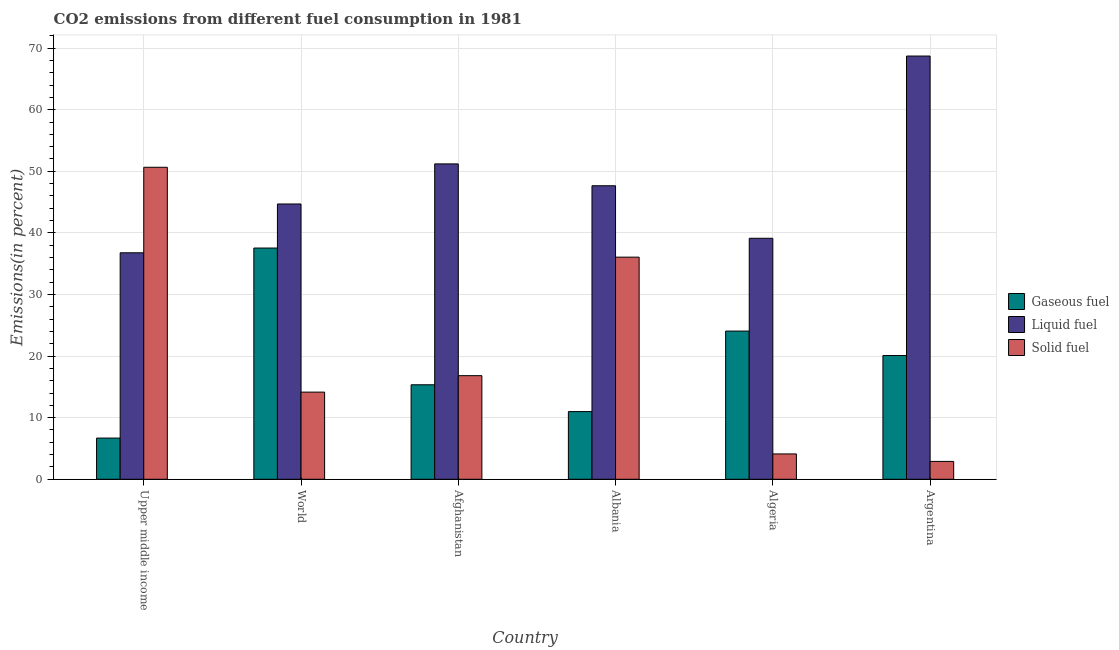How many different coloured bars are there?
Your answer should be very brief. 3. Are the number of bars per tick equal to the number of legend labels?
Your response must be concise. Yes. Are the number of bars on each tick of the X-axis equal?
Your answer should be compact. Yes. How many bars are there on the 1st tick from the left?
Your answer should be very brief. 3. In how many cases, is the number of bars for a given country not equal to the number of legend labels?
Give a very brief answer. 0. What is the percentage of liquid fuel emission in Albania?
Your response must be concise. 47.65. Across all countries, what is the maximum percentage of gaseous fuel emission?
Offer a terse response. 37.54. Across all countries, what is the minimum percentage of gaseous fuel emission?
Your response must be concise. 6.69. In which country was the percentage of gaseous fuel emission minimum?
Offer a very short reply. Upper middle income. What is the total percentage of liquid fuel emission in the graph?
Give a very brief answer. 288.16. What is the difference between the percentage of solid fuel emission in Upper middle income and that in World?
Offer a very short reply. 36.5. What is the difference between the percentage of solid fuel emission in Afghanistan and the percentage of gaseous fuel emission in Algeria?
Make the answer very short. -7.24. What is the average percentage of solid fuel emission per country?
Give a very brief answer. 20.78. What is the difference between the percentage of solid fuel emission and percentage of liquid fuel emission in Argentina?
Your answer should be compact. -65.81. In how many countries, is the percentage of gaseous fuel emission greater than 6 %?
Offer a terse response. 6. What is the ratio of the percentage of liquid fuel emission in Algeria to that in Argentina?
Provide a succinct answer. 0.57. What is the difference between the highest and the second highest percentage of liquid fuel emission?
Your response must be concise. 17.51. What is the difference between the highest and the lowest percentage of solid fuel emission?
Provide a short and direct response. 47.75. In how many countries, is the percentage of gaseous fuel emission greater than the average percentage of gaseous fuel emission taken over all countries?
Provide a short and direct response. 3. What does the 2nd bar from the left in World represents?
Provide a short and direct response. Liquid fuel. What does the 2nd bar from the right in Afghanistan represents?
Make the answer very short. Liquid fuel. Is it the case that in every country, the sum of the percentage of gaseous fuel emission and percentage of liquid fuel emission is greater than the percentage of solid fuel emission?
Provide a short and direct response. No. How many bars are there?
Make the answer very short. 18. Does the graph contain any zero values?
Offer a very short reply. No. Where does the legend appear in the graph?
Provide a succinct answer. Center right. How many legend labels are there?
Give a very brief answer. 3. How are the legend labels stacked?
Ensure brevity in your answer.  Vertical. What is the title of the graph?
Provide a succinct answer. CO2 emissions from different fuel consumption in 1981. What is the label or title of the Y-axis?
Keep it short and to the point. Emissions(in percent). What is the Emissions(in percent) in Gaseous fuel in Upper middle income?
Provide a succinct answer. 6.69. What is the Emissions(in percent) of Liquid fuel in Upper middle income?
Your response must be concise. 36.77. What is the Emissions(in percent) in Solid fuel in Upper middle income?
Offer a very short reply. 50.65. What is the Emissions(in percent) in Gaseous fuel in World?
Offer a very short reply. 37.54. What is the Emissions(in percent) in Liquid fuel in World?
Keep it short and to the point. 44.69. What is the Emissions(in percent) of Solid fuel in World?
Give a very brief answer. 14.15. What is the Emissions(in percent) in Gaseous fuel in Afghanistan?
Ensure brevity in your answer.  15.34. What is the Emissions(in percent) of Liquid fuel in Afghanistan?
Make the answer very short. 51.2. What is the Emissions(in percent) in Solid fuel in Afghanistan?
Provide a succinct answer. 16.82. What is the Emissions(in percent) in Gaseous fuel in Albania?
Offer a very short reply. 10.99. What is the Emissions(in percent) of Liquid fuel in Albania?
Give a very brief answer. 47.65. What is the Emissions(in percent) of Solid fuel in Albania?
Your response must be concise. 36.06. What is the Emissions(in percent) of Gaseous fuel in Algeria?
Offer a terse response. 24.06. What is the Emissions(in percent) in Liquid fuel in Algeria?
Your answer should be compact. 39.13. What is the Emissions(in percent) in Solid fuel in Algeria?
Make the answer very short. 4.11. What is the Emissions(in percent) in Gaseous fuel in Argentina?
Your answer should be compact. 20.09. What is the Emissions(in percent) in Liquid fuel in Argentina?
Your response must be concise. 68.71. What is the Emissions(in percent) in Solid fuel in Argentina?
Make the answer very short. 2.9. Across all countries, what is the maximum Emissions(in percent) in Gaseous fuel?
Your response must be concise. 37.54. Across all countries, what is the maximum Emissions(in percent) in Liquid fuel?
Give a very brief answer. 68.71. Across all countries, what is the maximum Emissions(in percent) in Solid fuel?
Your response must be concise. 50.65. Across all countries, what is the minimum Emissions(in percent) of Gaseous fuel?
Keep it short and to the point. 6.69. Across all countries, what is the minimum Emissions(in percent) of Liquid fuel?
Keep it short and to the point. 36.77. Across all countries, what is the minimum Emissions(in percent) of Solid fuel?
Provide a short and direct response. 2.9. What is the total Emissions(in percent) in Gaseous fuel in the graph?
Give a very brief answer. 114.72. What is the total Emissions(in percent) of Liquid fuel in the graph?
Make the answer very short. 288.16. What is the total Emissions(in percent) of Solid fuel in the graph?
Ensure brevity in your answer.  124.7. What is the difference between the Emissions(in percent) of Gaseous fuel in Upper middle income and that in World?
Your answer should be compact. -30.85. What is the difference between the Emissions(in percent) of Liquid fuel in Upper middle income and that in World?
Your response must be concise. -7.92. What is the difference between the Emissions(in percent) in Solid fuel in Upper middle income and that in World?
Provide a short and direct response. 36.51. What is the difference between the Emissions(in percent) of Gaseous fuel in Upper middle income and that in Afghanistan?
Your response must be concise. -8.65. What is the difference between the Emissions(in percent) of Liquid fuel in Upper middle income and that in Afghanistan?
Ensure brevity in your answer.  -14.43. What is the difference between the Emissions(in percent) in Solid fuel in Upper middle income and that in Afghanistan?
Make the answer very short. 33.83. What is the difference between the Emissions(in percent) in Gaseous fuel in Upper middle income and that in Albania?
Offer a terse response. -4.3. What is the difference between the Emissions(in percent) of Liquid fuel in Upper middle income and that in Albania?
Provide a short and direct response. -10.88. What is the difference between the Emissions(in percent) of Solid fuel in Upper middle income and that in Albania?
Provide a succinct answer. 14.59. What is the difference between the Emissions(in percent) of Gaseous fuel in Upper middle income and that in Algeria?
Offer a very short reply. -17.37. What is the difference between the Emissions(in percent) in Liquid fuel in Upper middle income and that in Algeria?
Offer a very short reply. -2.36. What is the difference between the Emissions(in percent) in Solid fuel in Upper middle income and that in Algeria?
Offer a terse response. 46.54. What is the difference between the Emissions(in percent) in Gaseous fuel in Upper middle income and that in Argentina?
Your answer should be very brief. -13.4. What is the difference between the Emissions(in percent) of Liquid fuel in Upper middle income and that in Argentina?
Your answer should be very brief. -31.94. What is the difference between the Emissions(in percent) of Solid fuel in Upper middle income and that in Argentina?
Offer a terse response. 47.75. What is the difference between the Emissions(in percent) of Gaseous fuel in World and that in Afghanistan?
Give a very brief answer. 22.2. What is the difference between the Emissions(in percent) of Liquid fuel in World and that in Afghanistan?
Offer a very short reply. -6.51. What is the difference between the Emissions(in percent) in Solid fuel in World and that in Afghanistan?
Your response must be concise. -2.67. What is the difference between the Emissions(in percent) of Gaseous fuel in World and that in Albania?
Provide a short and direct response. 26.55. What is the difference between the Emissions(in percent) in Liquid fuel in World and that in Albania?
Your response must be concise. -2.96. What is the difference between the Emissions(in percent) of Solid fuel in World and that in Albania?
Your response must be concise. -21.91. What is the difference between the Emissions(in percent) in Gaseous fuel in World and that in Algeria?
Provide a short and direct response. 13.48. What is the difference between the Emissions(in percent) in Liquid fuel in World and that in Algeria?
Your answer should be compact. 5.57. What is the difference between the Emissions(in percent) in Solid fuel in World and that in Algeria?
Provide a short and direct response. 10.04. What is the difference between the Emissions(in percent) in Gaseous fuel in World and that in Argentina?
Your answer should be very brief. 17.45. What is the difference between the Emissions(in percent) in Liquid fuel in World and that in Argentina?
Your answer should be compact. -24.02. What is the difference between the Emissions(in percent) of Solid fuel in World and that in Argentina?
Make the answer very short. 11.25. What is the difference between the Emissions(in percent) of Gaseous fuel in Afghanistan and that in Albania?
Make the answer very short. 4.35. What is the difference between the Emissions(in percent) of Liquid fuel in Afghanistan and that in Albania?
Make the answer very short. 3.55. What is the difference between the Emissions(in percent) in Solid fuel in Afghanistan and that in Albania?
Make the answer very short. -19.24. What is the difference between the Emissions(in percent) of Gaseous fuel in Afghanistan and that in Algeria?
Ensure brevity in your answer.  -8.72. What is the difference between the Emissions(in percent) of Liquid fuel in Afghanistan and that in Algeria?
Your answer should be very brief. 12.07. What is the difference between the Emissions(in percent) in Solid fuel in Afghanistan and that in Algeria?
Your answer should be compact. 12.71. What is the difference between the Emissions(in percent) of Gaseous fuel in Afghanistan and that in Argentina?
Your answer should be compact. -4.75. What is the difference between the Emissions(in percent) of Liquid fuel in Afghanistan and that in Argentina?
Provide a short and direct response. -17.51. What is the difference between the Emissions(in percent) of Solid fuel in Afghanistan and that in Argentina?
Offer a very short reply. 13.92. What is the difference between the Emissions(in percent) of Gaseous fuel in Albania and that in Algeria?
Ensure brevity in your answer.  -13.07. What is the difference between the Emissions(in percent) in Liquid fuel in Albania and that in Algeria?
Keep it short and to the point. 8.53. What is the difference between the Emissions(in percent) of Solid fuel in Albania and that in Algeria?
Your answer should be compact. 31.95. What is the difference between the Emissions(in percent) in Gaseous fuel in Albania and that in Argentina?
Your answer should be very brief. -9.1. What is the difference between the Emissions(in percent) in Liquid fuel in Albania and that in Argentina?
Offer a very short reply. -21.06. What is the difference between the Emissions(in percent) in Solid fuel in Albania and that in Argentina?
Offer a terse response. 33.16. What is the difference between the Emissions(in percent) of Gaseous fuel in Algeria and that in Argentina?
Your answer should be compact. 3.97. What is the difference between the Emissions(in percent) of Liquid fuel in Algeria and that in Argentina?
Give a very brief answer. -29.59. What is the difference between the Emissions(in percent) of Solid fuel in Algeria and that in Argentina?
Give a very brief answer. 1.21. What is the difference between the Emissions(in percent) of Gaseous fuel in Upper middle income and the Emissions(in percent) of Liquid fuel in World?
Provide a short and direct response. -38.01. What is the difference between the Emissions(in percent) of Gaseous fuel in Upper middle income and the Emissions(in percent) of Solid fuel in World?
Keep it short and to the point. -7.46. What is the difference between the Emissions(in percent) in Liquid fuel in Upper middle income and the Emissions(in percent) in Solid fuel in World?
Provide a short and direct response. 22.62. What is the difference between the Emissions(in percent) of Gaseous fuel in Upper middle income and the Emissions(in percent) of Liquid fuel in Afghanistan?
Make the answer very short. -44.51. What is the difference between the Emissions(in percent) in Gaseous fuel in Upper middle income and the Emissions(in percent) in Solid fuel in Afghanistan?
Provide a short and direct response. -10.13. What is the difference between the Emissions(in percent) in Liquid fuel in Upper middle income and the Emissions(in percent) in Solid fuel in Afghanistan?
Your answer should be very brief. 19.95. What is the difference between the Emissions(in percent) of Gaseous fuel in Upper middle income and the Emissions(in percent) of Liquid fuel in Albania?
Offer a very short reply. -40.96. What is the difference between the Emissions(in percent) of Gaseous fuel in Upper middle income and the Emissions(in percent) of Solid fuel in Albania?
Provide a short and direct response. -29.37. What is the difference between the Emissions(in percent) of Liquid fuel in Upper middle income and the Emissions(in percent) of Solid fuel in Albania?
Your answer should be compact. 0.71. What is the difference between the Emissions(in percent) of Gaseous fuel in Upper middle income and the Emissions(in percent) of Liquid fuel in Algeria?
Your answer should be very brief. -32.44. What is the difference between the Emissions(in percent) of Gaseous fuel in Upper middle income and the Emissions(in percent) of Solid fuel in Algeria?
Your answer should be compact. 2.58. What is the difference between the Emissions(in percent) of Liquid fuel in Upper middle income and the Emissions(in percent) of Solid fuel in Algeria?
Offer a very short reply. 32.66. What is the difference between the Emissions(in percent) of Gaseous fuel in Upper middle income and the Emissions(in percent) of Liquid fuel in Argentina?
Provide a succinct answer. -62.02. What is the difference between the Emissions(in percent) of Gaseous fuel in Upper middle income and the Emissions(in percent) of Solid fuel in Argentina?
Provide a succinct answer. 3.79. What is the difference between the Emissions(in percent) in Liquid fuel in Upper middle income and the Emissions(in percent) in Solid fuel in Argentina?
Your answer should be very brief. 33.87. What is the difference between the Emissions(in percent) in Gaseous fuel in World and the Emissions(in percent) in Liquid fuel in Afghanistan?
Your response must be concise. -13.66. What is the difference between the Emissions(in percent) in Gaseous fuel in World and the Emissions(in percent) in Solid fuel in Afghanistan?
Make the answer very short. 20.72. What is the difference between the Emissions(in percent) in Liquid fuel in World and the Emissions(in percent) in Solid fuel in Afghanistan?
Your response must be concise. 27.87. What is the difference between the Emissions(in percent) in Gaseous fuel in World and the Emissions(in percent) in Liquid fuel in Albania?
Offer a very short reply. -10.11. What is the difference between the Emissions(in percent) of Gaseous fuel in World and the Emissions(in percent) of Solid fuel in Albania?
Ensure brevity in your answer.  1.48. What is the difference between the Emissions(in percent) in Liquid fuel in World and the Emissions(in percent) in Solid fuel in Albania?
Give a very brief answer. 8.63. What is the difference between the Emissions(in percent) in Gaseous fuel in World and the Emissions(in percent) in Liquid fuel in Algeria?
Your response must be concise. -1.58. What is the difference between the Emissions(in percent) in Gaseous fuel in World and the Emissions(in percent) in Solid fuel in Algeria?
Your answer should be very brief. 33.43. What is the difference between the Emissions(in percent) of Liquid fuel in World and the Emissions(in percent) of Solid fuel in Algeria?
Make the answer very short. 40.58. What is the difference between the Emissions(in percent) of Gaseous fuel in World and the Emissions(in percent) of Liquid fuel in Argentina?
Provide a succinct answer. -31.17. What is the difference between the Emissions(in percent) in Gaseous fuel in World and the Emissions(in percent) in Solid fuel in Argentina?
Your answer should be compact. 34.64. What is the difference between the Emissions(in percent) of Liquid fuel in World and the Emissions(in percent) of Solid fuel in Argentina?
Your answer should be compact. 41.79. What is the difference between the Emissions(in percent) in Gaseous fuel in Afghanistan and the Emissions(in percent) in Liquid fuel in Albania?
Ensure brevity in your answer.  -32.31. What is the difference between the Emissions(in percent) of Gaseous fuel in Afghanistan and the Emissions(in percent) of Solid fuel in Albania?
Keep it short and to the point. -20.72. What is the difference between the Emissions(in percent) in Liquid fuel in Afghanistan and the Emissions(in percent) in Solid fuel in Albania?
Provide a succinct answer. 15.14. What is the difference between the Emissions(in percent) of Gaseous fuel in Afghanistan and the Emissions(in percent) of Liquid fuel in Algeria?
Keep it short and to the point. -23.78. What is the difference between the Emissions(in percent) of Gaseous fuel in Afghanistan and the Emissions(in percent) of Solid fuel in Algeria?
Provide a short and direct response. 11.23. What is the difference between the Emissions(in percent) in Liquid fuel in Afghanistan and the Emissions(in percent) in Solid fuel in Algeria?
Ensure brevity in your answer.  47.09. What is the difference between the Emissions(in percent) of Gaseous fuel in Afghanistan and the Emissions(in percent) of Liquid fuel in Argentina?
Provide a succinct answer. -53.37. What is the difference between the Emissions(in percent) in Gaseous fuel in Afghanistan and the Emissions(in percent) in Solid fuel in Argentina?
Your answer should be very brief. 12.44. What is the difference between the Emissions(in percent) in Liquid fuel in Afghanistan and the Emissions(in percent) in Solid fuel in Argentina?
Offer a terse response. 48.3. What is the difference between the Emissions(in percent) in Gaseous fuel in Albania and the Emissions(in percent) in Liquid fuel in Algeria?
Offer a terse response. -28.14. What is the difference between the Emissions(in percent) of Gaseous fuel in Albania and the Emissions(in percent) of Solid fuel in Algeria?
Provide a succinct answer. 6.88. What is the difference between the Emissions(in percent) of Liquid fuel in Albania and the Emissions(in percent) of Solid fuel in Algeria?
Ensure brevity in your answer.  43.54. What is the difference between the Emissions(in percent) of Gaseous fuel in Albania and the Emissions(in percent) of Liquid fuel in Argentina?
Offer a terse response. -57.72. What is the difference between the Emissions(in percent) in Gaseous fuel in Albania and the Emissions(in percent) in Solid fuel in Argentina?
Ensure brevity in your answer.  8.09. What is the difference between the Emissions(in percent) of Liquid fuel in Albania and the Emissions(in percent) of Solid fuel in Argentina?
Your answer should be very brief. 44.75. What is the difference between the Emissions(in percent) in Gaseous fuel in Algeria and the Emissions(in percent) in Liquid fuel in Argentina?
Ensure brevity in your answer.  -44.65. What is the difference between the Emissions(in percent) of Gaseous fuel in Algeria and the Emissions(in percent) of Solid fuel in Argentina?
Provide a short and direct response. 21.16. What is the difference between the Emissions(in percent) of Liquid fuel in Algeria and the Emissions(in percent) of Solid fuel in Argentina?
Offer a very short reply. 36.23. What is the average Emissions(in percent) in Gaseous fuel per country?
Provide a succinct answer. 19.12. What is the average Emissions(in percent) in Liquid fuel per country?
Keep it short and to the point. 48.03. What is the average Emissions(in percent) in Solid fuel per country?
Make the answer very short. 20.78. What is the difference between the Emissions(in percent) in Gaseous fuel and Emissions(in percent) in Liquid fuel in Upper middle income?
Your response must be concise. -30.08. What is the difference between the Emissions(in percent) of Gaseous fuel and Emissions(in percent) of Solid fuel in Upper middle income?
Provide a short and direct response. -43.96. What is the difference between the Emissions(in percent) of Liquid fuel and Emissions(in percent) of Solid fuel in Upper middle income?
Offer a very short reply. -13.88. What is the difference between the Emissions(in percent) of Gaseous fuel and Emissions(in percent) of Liquid fuel in World?
Offer a very short reply. -7.15. What is the difference between the Emissions(in percent) in Gaseous fuel and Emissions(in percent) in Solid fuel in World?
Offer a very short reply. 23.39. What is the difference between the Emissions(in percent) of Liquid fuel and Emissions(in percent) of Solid fuel in World?
Give a very brief answer. 30.55. What is the difference between the Emissions(in percent) in Gaseous fuel and Emissions(in percent) in Liquid fuel in Afghanistan?
Offer a terse response. -35.86. What is the difference between the Emissions(in percent) of Gaseous fuel and Emissions(in percent) of Solid fuel in Afghanistan?
Give a very brief answer. -1.48. What is the difference between the Emissions(in percent) in Liquid fuel and Emissions(in percent) in Solid fuel in Afghanistan?
Your response must be concise. 34.38. What is the difference between the Emissions(in percent) of Gaseous fuel and Emissions(in percent) of Liquid fuel in Albania?
Make the answer very short. -36.66. What is the difference between the Emissions(in percent) in Gaseous fuel and Emissions(in percent) in Solid fuel in Albania?
Provide a short and direct response. -25.07. What is the difference between the Emissions(in percent) of Liquid fuel and Emissions(in percent) of Solid fuel in Albania?
Provide a short and direct response. 11.59. What is the difference between the Emissions(in percent) of Gaseous fuel and Emissions(in percent) of Liquid fuel in Algeria?
Offer a very short reply. -15.07. What is the difference between the Emissions(in percent) of Gaseous fuel and Emissions(in percent) of Solid fuel in Algeria?
Keep it short and to the point. 19.95. What is the difference between the Emissions(in percent) in Liquid fuel and Emissions(in percent) in Solid fuel in Algeria?
Give a very brief answer. 35.01. What is the difference between the Emissions(in percent) of Gaseous fuel and Emissions(in percent) of Liquid fuel in Argentina?
Make the answer very short. -48.62. What is the difference between the Emissions(in percent) in Gaseous fuel and Emissions(in percent) in Solid fuel in Argentina?
Offer a very short reply. 17.19. What is the difference between the Emissions(in percent) in Liquid fuel and Emissions(in percent) in Solid fuel in Argentina?
Give a very brief answer. 65.81. What is the ratio of the Emissions(in percent) of Gaseous fuel in Upper middle income to that in World?
Give a very brief answer. 0.18. What is the ratio of the Emissions(in percent) of Liquid fuel in Upper middle income to that in World?
Provide a short and direct response. 0.82. What is the ratio of the Emissions(in percent) in Solid fuel in Upper middle income to that in World?
Your response must be concise. 3.58. What is the ratio of the Emissions(in percent) in Gaseous fuel in Upper middle income to that in Afghanistan?
Your answer should be very brief. 0.44. What is the ratio of the Emissions(in percent) in Liquid fuel in Upper middle income to that in Afghanistan?
Offer a very short reply. 0.72. What is the ratio of the Emissions(in percent) in Solid fuel in Upper middle income to that in Afghanistan?
Provide a succinct answer. 3.01. What is the ratio of the Emissions(in percent) of Gaseous fuel in Upper middle income to that in Albania?
Offer a terse response. 0.61. What is the ratio of the Emissions(in percent) of Liquid fuel in Upper middle income to that in Albania?
Provide a short and direct response. 0.77. What is the ratio of the Emissions(in percent) in Solid fuel in Upper middle income to that in Albania?
Your answer should be very brief. 1.4. What is the ratio of the Emissions(in percent) in Gaseous fuel in Upper middle income to that in Algeria?
Offer a very short reply. 0.28. What is the ratio of the Emissions(in percent) in Liquid fuel in Upper middle income to that in Algeria?
Offer a terse response. 0.94. What is the ratio of the Emissions(in percent) of Solid fuel in Upper middle income to that in Algeria?
Your answer should be compact. 12.31. What is the ratio of the Emissions(in percent) of Gaseous fuel in Upper middle income to that in Argentina?
Give a very brief answer. 0.33. What is the ratio of the Emissions(in percent) of Liquid fuel in Upper middle income to that in Argentina?
Give a very brief answer. 0.54. What is the ratio of the Emissions(in percent) of Solid fuel in Upper middle income to that in Argentina?
Your answer should be compact. 17.47. What is the ratio of the Emissions(in percent) in Gaseous fuel in World to that in Afghanistan?
Your response must be concise. 2.45. What is the ratio of the Emissions(in percent) in Liquid fuel in World to that in Afghanistan?
Offer a very short reply. 0.87. What is the ratio of the Emissions(in percent) of Solid fuel in World to that in Afghanistan?
Give a very brief answer. 0.84. What is the ratio of the Emissions(in percent) of Gaseous fuel in World to that in Albania?
Provide a short and direct response. 3.42. What is the ratio of the Emissions(in percent) in Liquid fuel in World to that in Albania?
Your response must be concise. 0.94. What is the ratio of the Emissions(in percent) in Solid fuel in World to that in Albania?
Offer a very short reply. 0.39. What is the ratio of the Emissions(in percent) of Gaseous fuel in World to that in Algeria?
Make the answer very short. 1.56. What is the ratio of the Emissions(in percent) in Liquid fuel in World to that in Algeria?
Offer a very short reply. 1.14. What is the ratio of the Emissions(in percent) in Solid fuel in World to that in Algeria?
Ensure brevity in your answer.  3.44. What is the ratio of the Emissions(in percent) in Gaseous fuel in World to that in Argentina?
Your answer should be compact. 1.87. What is the ratio of the Emissions(in percent) of Liquid fuel in World to that in Argentina?
Offer a terse response. 0.65. What is the ratio of the Emissions(in percent) in Solid fuel in World to that in Argentina?
Provide a short and direct response. 4.88. What is the ratio of the Emissions(in percent) of Gaseous fuel in Afghanistan to that in Albania?
Provide a succinct answer. 1.4. What is the ratio of the Emissions(in percent) in Liquid fuel in Afghanistan to that in Albania?
Provide a short and direct response. 1.07. What is the ratio of the Emissions(in percent) in Solid fuel in Afghanistan to that in Albania?
Give a very brief answer. 0.47. What is the ratio of the Emissions(in percent) of Gaseous fuel in Afghanistan to that in Algeria?
Provide a succinct answer. 0.64. What is the ratio of the Emissions(in percent) of Liquid fuel in Afghanistan to that in Algeria?
Provide a short and direct response. 1.31. What is the ratio of the Emissions(in percent) of Solid fuel in Afghanistan to that in Algeria?
Make the answer very short. 4.09. What is the ratio of the Emissions(in percent) of Gaseous fuel in Afghanistan to that in Argentina?
Give a very brief answer. 0.76. What is the ratio of the Emissions(in percent) of Liquid fuel in Afghanistan to that in Argentina?
Keep it short and to the point. 0.75. What is the ratio of the Emissions(in percent) of Solid fuel in Afghanistan to that in Argentina?
Keep it short and to the point. 5.8. What is the ratio of the Emissions(in percent) in Gaseous fuel in Albania to that in Algeria?
Give a very brief answer. 0.46. What is the ratio of the Emissions(in percent) of Liquid fuel in Albania to that in Algeria?
Make the answer very short. 1.22. What is the ratio of the Emissions(in percent) of Solid fuel in Albania to that in Algeria?
Provide a short and direct response. 8.77. What is the ratio of the Emissions(in percent) of Gaseous fuel in Albania to that in Argentina?
Your answer should be compact. 0.55. What is the ratio of the Emissions(in percent) in Liquid fuel in Albania to that in Argentina?
Provide a succinct answer. 0.69. What is the ratio of the Emissions(in percent) in Solid fuel in Albania to that in Argentina?
Your answer should be compact. 12.44. What is the ratio of the Emissions(in percent) in Gaseous fuel in Algeria to that in Argentina?
Keep it short and to the point. 1.2. What is the ratio of the Emissions(in percent) in Liquid fuel in Algeria to that in Argentina?
Provide a short and direct response. 0.57. What is the ratio of the Emissions(in percent) of Solid fuel in Algeria to that in Argentina?
Ensure brevity in your answer.  1.42. What is the difference between the highest and the second highest Emissions(in percent) in Gaseous fuel?
Provide a succinct answer. 13.48. What is the difference between the highest and the second highest Emissions(in percent) in Liquid fuel?
Keep it short and to the point. 17.51. What is the difference between the highest and the second highest Emissions(in percent) in Solid fuel?
Make the answer very short. 14.59. What is the difference between the highest and the lowest Emissions(in percent) of Gaseous fuel?
Offer a very short reply. 30.85. What is the difference between the highest and the lowest Emissions(in percent) of Liquid fuel?
Provide a short and direct response. 31.94. What is the difference between the highest and the lowest Emissions(in percent) in Solid fuel?
Your response must be concise. 47.75. 